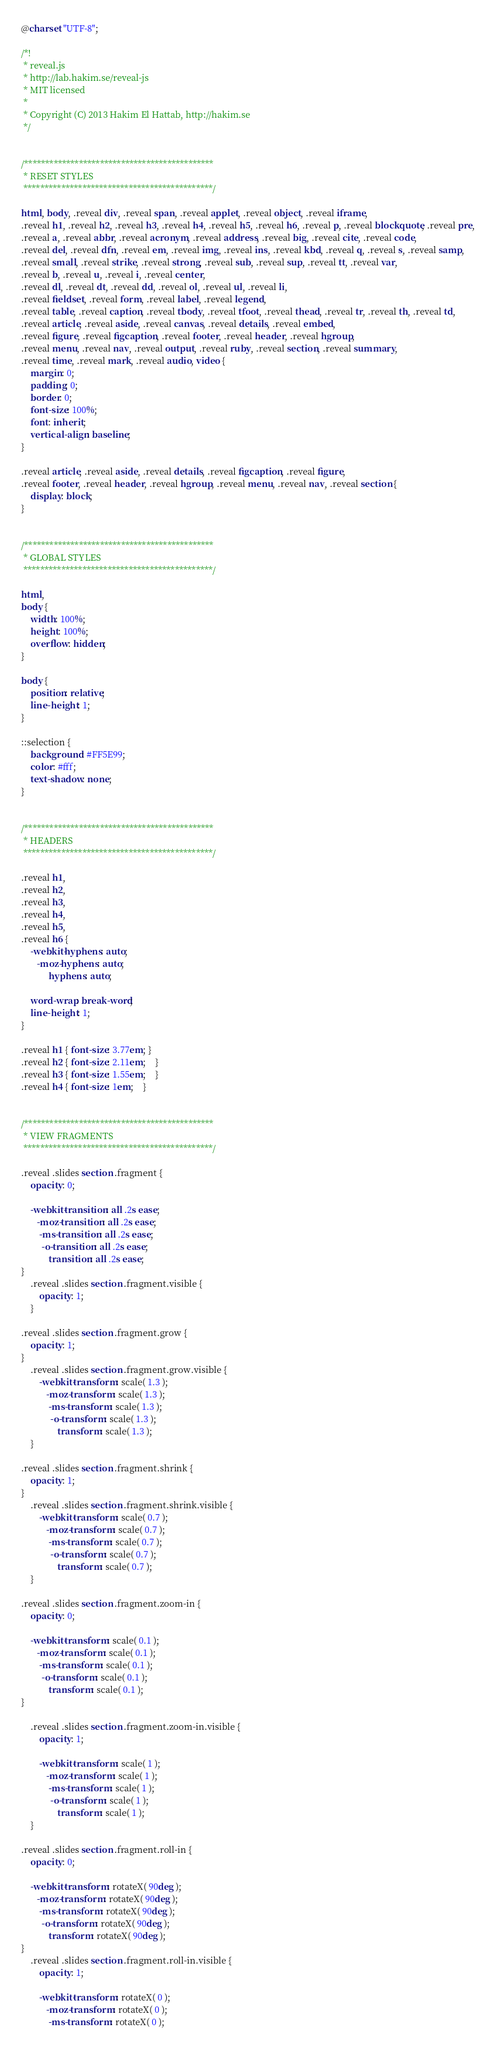<code> <loc_0><loc_0><loc_500><loc_500><_CSS_>@charset "UTF-8";

/*!
 * reveal.js
 * http://lab.hakim.se/reveal-js
 * MIT licensed
 *
 * Copyright (C) 2013 Hakim El Hattab, http://hakim.se
 */


/*********************************************
 * RESET STYLES
 *********************************************/

html, body, .reveal div, .reveal span, .reveal applet, .reveal object, .reveal iframe,
.reveal h1, .reveal h2, .reveal h3, .reveal h4, .reveal h5, .reveal h6, .reveal p, .reveal blockquote, .reveal pre,
.reveal a, .reveal abbr, .reveal acronym, .reveal address, .reveal big, .reveal cite, .reveal code,
.reveal del, .reveal dfn, .reveal em, .reveal img, .reveal ins, .reveal kbd, .reveal q, .reveal s, .reveal samp,
.reveal small, .reveal strike, .reveal strong, .reveal sub, .reveal sup, .reveal tt, .reveal var,
.reveal b, .reveal u, .reveal i, .reveal center,
.reveal dl, .reveal dt, .reveal dd, .reveal ol, .reveal ul, .reveal li,
.reveal fieldset, .reveal form, .reveal label, .reveal legend,
.reveal table, .reveal caption, .reveal tbody, .reveal tfoot, .reveal thead, .reveal tr, .reveal th, .reveal td,
.reveal article, .reveal aside, .reveal canvas, .reveal details, .reveal embed,
.reveal figure, .reveal figcaption, .reveal footer, .reveal header, .reveal hgroup,
.reveal menu, .reveal nav, .reveal output, .reveal ruby, .reveal section, .reveal summary,
.reveal time, .reveal mark, .reveal audio, video {
	margin: 0;
	padding: 0;
	border: 0;
	font-size: 100%;
	font: inherit;
	vertical-align: baseline;
}

.reveal article, .reveal aside, .reveal details, .reveal figcaption, .reveal figure,
.reveal footer, .reveal header, .reveal hgroup, .reveal menu, .reveal nav, .reveal section {
	display: block;
}


/*********************************************
 * GLOBAL STYLES
 *********************************************/

html,
body {
	width: 100%;
	height: 100%;
	overflow: hidden;
}

body {
	position: relative;
	line-height: 1;
}

::selection {
	background: #FF5E99;
	color: #fff;
	text-shadow: none;
}


/*********************************************
 * HEADERS
 *********************************************/

.reveal h1,
.reveal h2,
.reveal h3,
.reveal h4,
.reveal h5,
.reveal h6 {
	-webkit-hyphens: auto;
	   -moz-hyphens: auto;
	        hyphens: auto;

	word-wrap: break-word;
	line-height: 1;
}

.reveal h1 { font-size: 3.77em; }
.reveal h2 { font-size: 2.11em;	}
.reveal h3 { font-size: 1.55em;	}
.reveal h4 { font-size: 1em;	}


/*********************************************
 * VIEW FRAGMENTS
 *********************************************/

.reveal .slides section .fragment {
	opacity: 0;

	-webkit-transition: all .2s ease;
	   -moz-transition: all .2s ease;
	    -ms-transition: all .2s ease;
	     -o-transition: all .2s ease;
	        transition: all .2s ease;
}
	.reveal .slides section .fragment.visible {
		opacity: 1;
	}

.reveal .slides section .fragment.grow {
	opacity: 1;
}
	.reveal .slides section .fragment.grow.visible {
		-webkit-transform: scale( 1.3 );
		   -moz-transform: scale( 1.3 );
		    -ms-transform: scale( 1.3 );
		     -o-transform: scale( 1.3 );
		        transform: scale( 1.3 );
	}

.reveal .slides section .fragment.shrink {
	opacity: 1;
}
	.reveal .slides section .fragment.shrink.visible {
		-webkit-transform: scale( 0.7 );
		   -moz-transform: scale( 0.7 );
		    -ms-transform: scale( 0.7 );
		     -o-transform: scale( 0.7 );
		        transform: scale( 0.7 );
	}

.reveal .slides section .fragment.zoom-in {
	opacity: 0;

	-webkit-transform: scale( 0.1 );
	   -moz-transform: scale( 0.1 );
	    -ms-transform: scale( 0.1 );
	     -o-transform: scale( 0.1 );
	        transform: scale( 0.1 );
}

	.reveal .slides section .fragment.zoom-in.visible {
		opacity: 1;

		-webkit-transform: scale( 1 );
		   -moz-transform: scale( 1 );
		    -ms-transform: scale( 1 );
		     -o-transform: scale( 1 );
		        transform: scale( 1 );
	}

.reveal .slides section .fragment.roll-in {
	opacity: 0;

	-webkit-transform: rotateX( 90deg );
	   -moz-transform: rotateX( 90deg );
	    -ms-transform: rotateX( 90deg );
	     -o-transform: rotateX( 90deg );
	        transform: rotateX( 90deg );
}
	.reveal .slides section .fragment.roll-in.visible {
		opacity: 1;

		-webkit-transform: rotateX( 0 );
		   -moz-transform: rotateX( 0 );
		    -ms-transform: rotateX( 0 );</code> 